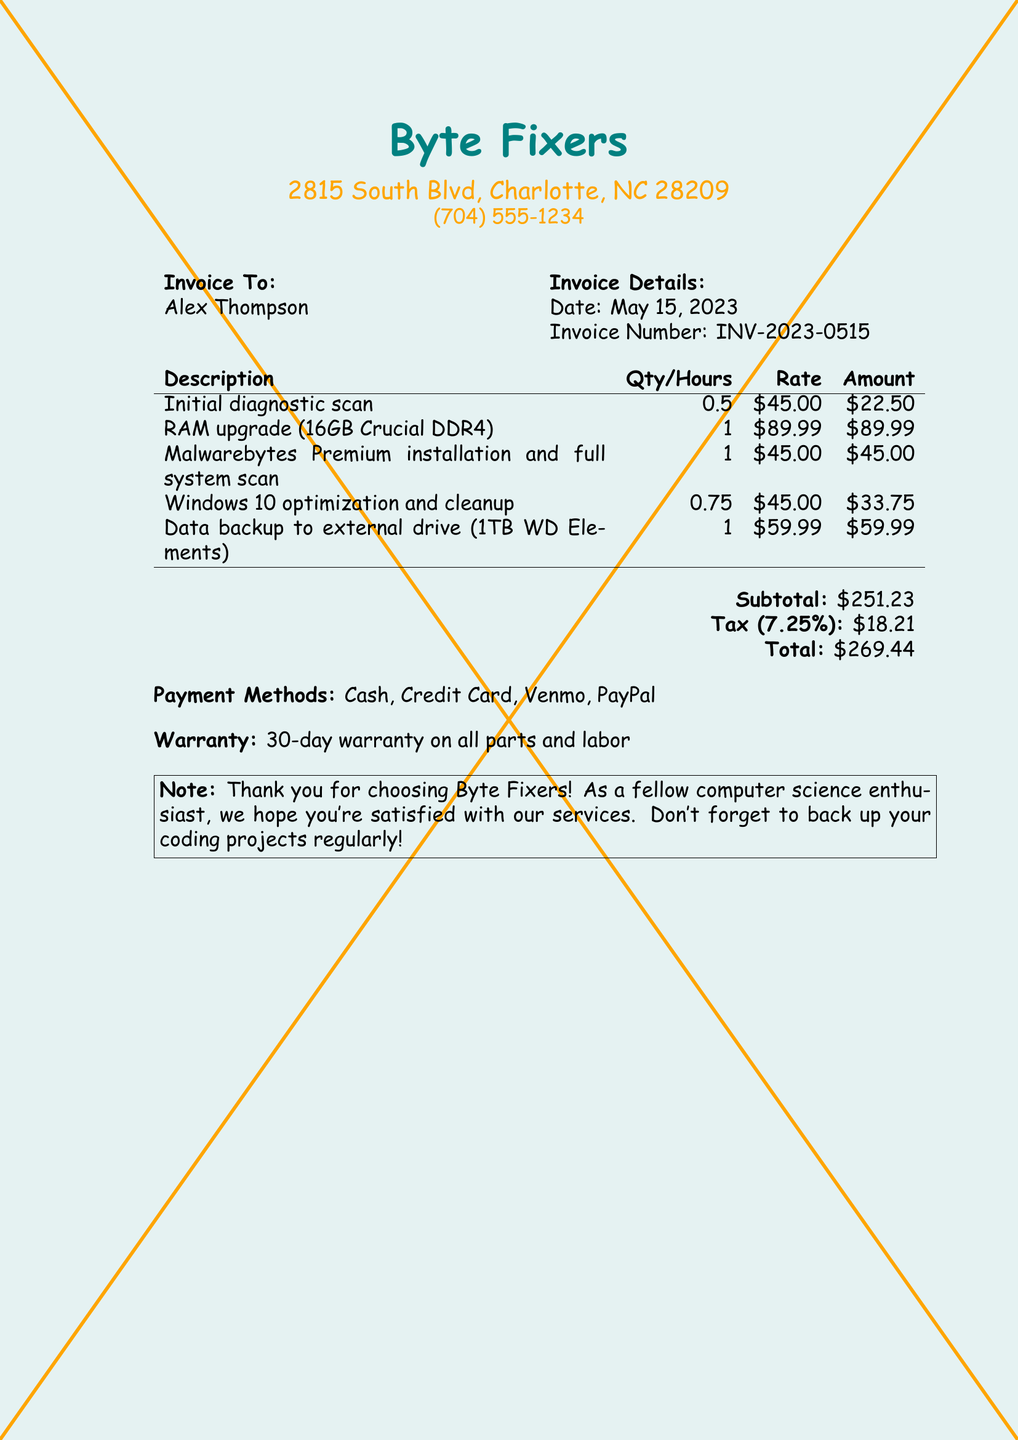What is the business name? The business name is listed at the top of the invoice.
Answer: Byte Fixers What is the invoice date? The date of the invoice appears in the details section.
Answer: May 15, 2023 What is the subtotal amount? The subtotal is calculated before tax and is listed in the invoice summary.
Answer: $251.23 How many hours were billed for the initial diagnostic scan? The hours for the service are indicated in the services table.
Answer: 0.5 What is the warranty period on services? The warranty information is provided in the invoice notes.
Answer: 30-day warranty What services include virus removal? Virus removal services can be deduced from the service descriptions listed.
Answer: Malwarebytes Premium installation and full system scan What is the total amount including tax? The total includes the subtotal and tax, found in the summary section.
Answer: $269.44 What payment methods are accepted? Accepted payment methods are listed separately in the document.
Answer: Cash, Credit Card, Venmo, PayPal How much was charged for the RAM upgrade? The price for the RAM upgrade is provided in the services table.
Answer: $89.99 